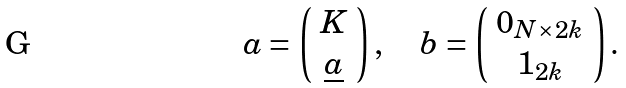Convert formula to latex. <formula><loc_0><loc_0><loc_500><loc_500>a = \left ( \begin{array} { c } K \\ \underline { a } \end{array} \right ) , \quad b = \left ( \begin{array} { c } 0 _ { N \times 2 k } \\ 1 _ { 2 k } \end{array} \right ) .</formula> 